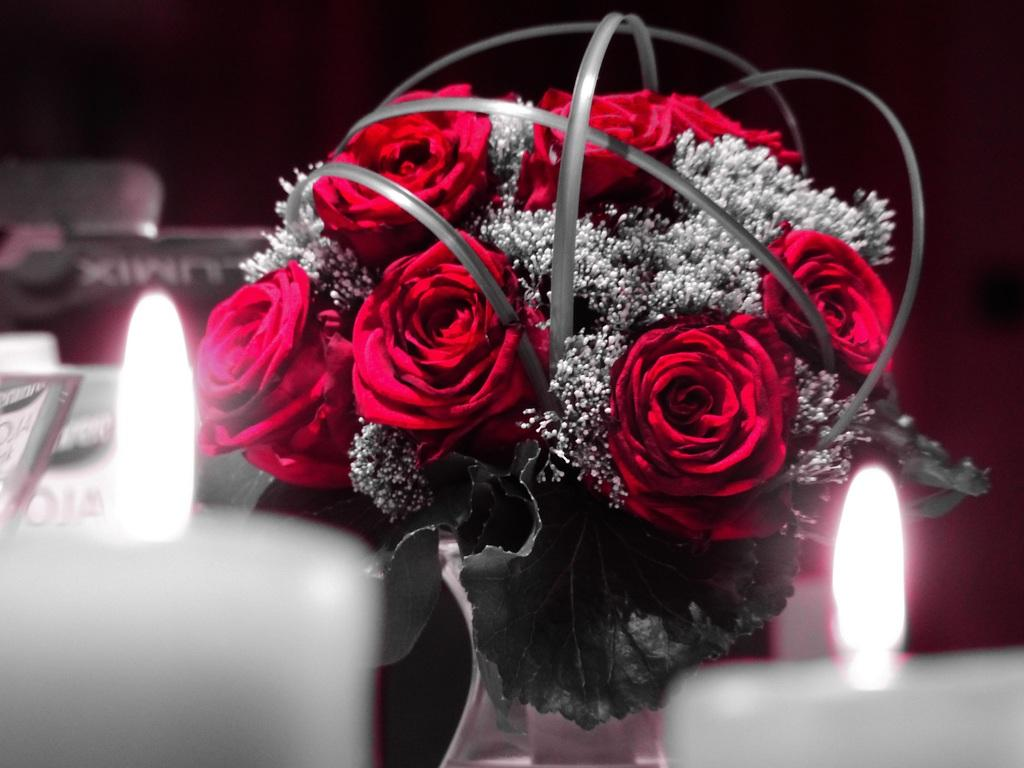What type of objects can be seen in the image? There are candles and a flower vase in the image. Are the candles in the image lit or unlit? The candles in the image are lit. What else can be seen in the image besides candles and the flower vase? There are other objects present in the image. How many tomatoes are being stitched by the spy in the image? There is no spy, tomatoes, or stitching activity present in the image. 